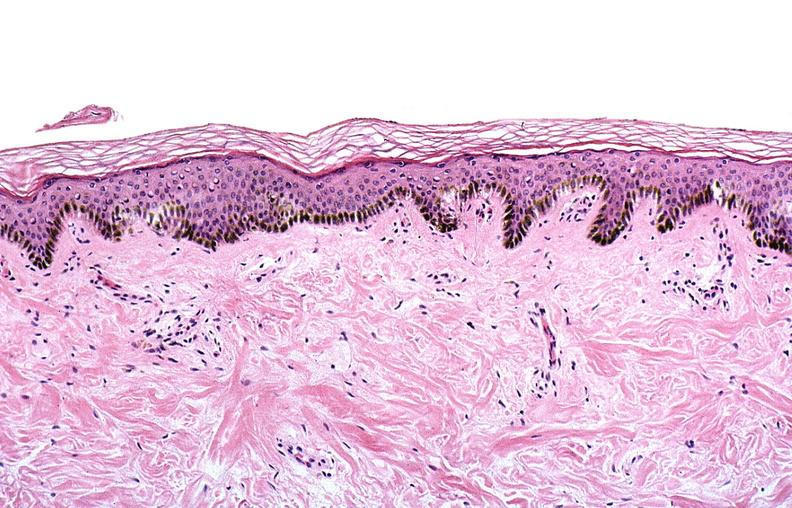does hematoma show thermal burned skin?
Answer the question using a single word or phrase. No 